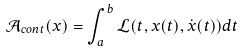Convert formula to latex. <formula><loc_0><loc_0><loc_500><loc_500>\mathcal { A } _ { c o n t } ( x ) = \int _ { a } ^ { b } \mathcal { L } ( t , x ( t ) , \dot { x } ( t ) ) d t</formula> 